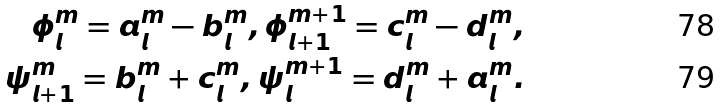Convert formula to latex. <formula><loc_0><loc_0><loc_500><loc_500>\phi _ { l } ^ { m } = a _ { l } ^ { m } - b _ { l } ^ { m } , \phi _ { l + 1 } ^ { m + 1 } = c _ { l } ^ { m } - d _ { l } ^ { m } , \\ \psi _ { l + 1 } ^ { m } = b _ { l } ^ { m } + c _ { l } ^ { m } , \psi _ { l } ^ { m + 1 } = d _ { l } ^ { m } + a _ { l } ^ { m } .</formula> 